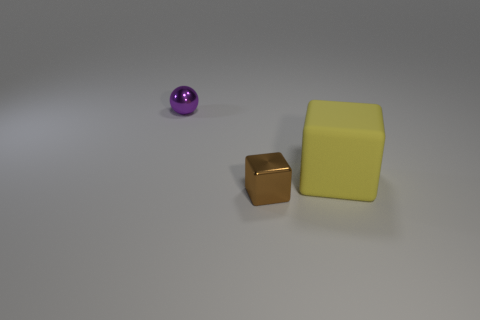Add 2 tiny metallic objects. How many objects exist? 5 Subtract all balls. How many objects are left? 2 Add 2 small things. How many small things are left? 4 Add 2 big yellow blocks. How many big yellow blocks exist? 3 Subtract 0 gray cubes. How many objects are left? 3 Subtract all small purple cylinders. Subtract all big rubber blocks. How many objects are left? 2 